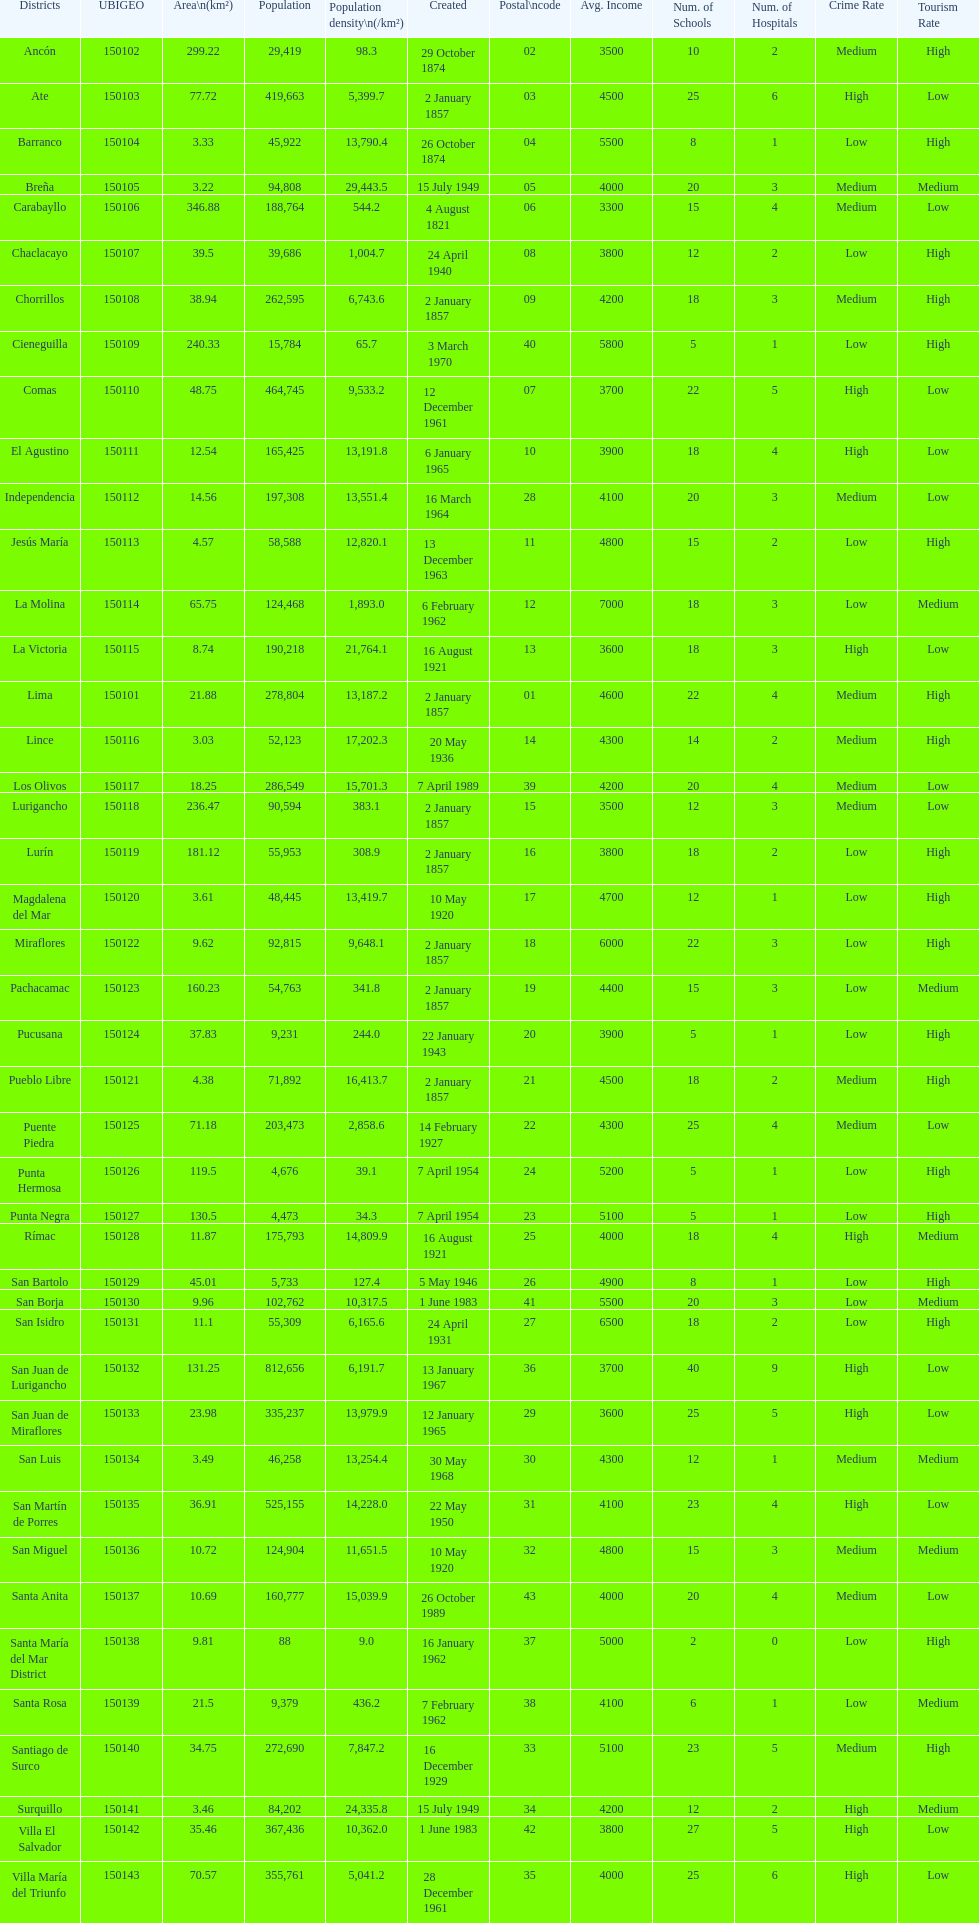What is the total number of districts of lima? 43. 